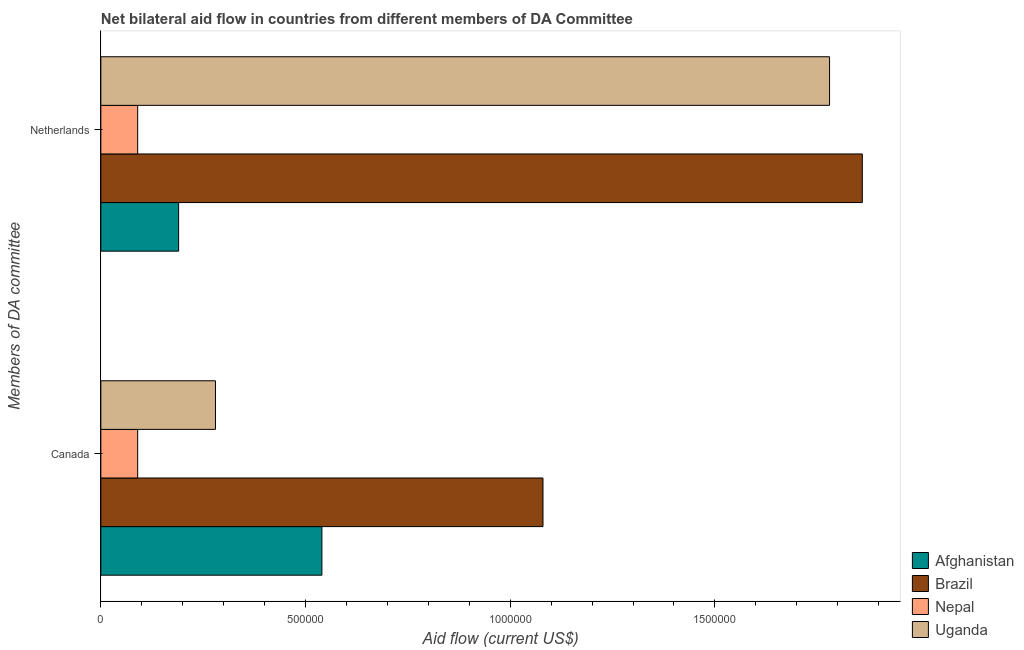How many groups of bars are there?
Offer a terse response. 2. Are the number of bars on each tick of the Y-axis equal?
Provide a succinct answer. Yes. How many bars are there on the 2nd tick from the top?
Offer a very short reply. 4. How many bars are there on the 1st tick from the bottom?
Provide a succinct answer. 4. What is the label of the 1st group of bars from the top?
Your response must be concise. Netherlands. What is the amount of aid given by canada in Uganda?
Offer a very short reply. 2.80e+05. Across all countries, what is the maximum amount of aid given by netherlands?
Provide a short and direct response. 1.86e+06. Across all countries, what is the minimum amount of aid given by netherlands?
Provide a short and direct response. 9.00e+04. In which country was the amount of aid given by netherlands maximum?
Offer a very short reply. Brazil. In which country was the amount of aid given by netherlands minimum?
Your answer should be very brief. Nepal. What is the total amount of aid given by canada in the graph?
Give a very brief answer. 1.99e+06. What is the difference between the amount of aid given by canada in Nepal and that in Brazil?
Ensure brevity in your answer.  -9.90e+05. What is the difference between the amount of aid given by canada in Afghanistan and the amount of aid given by netherlands in Uganda?
Your response must be concise. -1.24e+06. What is the average amount of aid given by canada per country?
Keep it short and to the point. 4.98e+05. What is the difference between the amount of aid given by netherlands and amount of aid given by canada in Brazil?
Keep it short and to the point. 7.80e+05. In how many countries, is the amount of aid given by netherlands greater than 1400000 US$?
Make the answer very short. 2. What is the ratio of the amount of aid given by canada in Brazil to that in Afghanistan?
Provide a short and direct response. 2. What does the 2nd bar from the top in Netherlands represents?
Provide a short and direct response. Nepal. What does the 1st bar from the bottom in Netherlands represents?
Provide a short and direct response. Afghanistan. How many bars are there?
Your answer should be compact. 8. Are all the bars in the graph horizontal?
Your response must be concise. Yes. What is the difference between two consecutive major ticks on the X-axis?
Provide a short and direct response. 5.00e+05. Are the values on the major ticks of X-axis written in scientific E-notation?
Keep it short and to the point. No. Does the graph contain grids?
Keep it short and to the point. No. How many legend labels are there?
Make the answer very short. 4. What is the title of the graph?
Give a very brief answer. Net bilateral aid flow in countries from different members of DA Committee. What is the label or title of the X-axis?
Your answer should be very brief. Aid flow (current US$). What is the label or title of the Y-axis?
Ensure brevity in your answer.  Members of DA committee. What is the Aid flow (current US$) of Afghanistan in Canada?
Provide a succinct answer. 5.40e+05. What is the Aid flow (current US$) of Brazil in Canada?
Your answer should be compact. 1.08e+06. What is the Aid flow (current US$) in Uganda in Canada?
Offer a very short reply. 2.80e+05. What is the Aid flow (current US$) of Brazil in Netherlands?
Keep it short and to the point. 1.86e+06. What is the Aid flow (current US$) of Uganda in Netherlands?
Offer a very short reply. 1.78e+06. Across all Members of DA committee, what is the maximum Aid flow (current US$) in Afghanistan?
Your answer should be compact. 5.40e+05. Across all Members of DA committee, what is the maximum Aid flow (current US$) of Brazil?
Your response must be concise. 1.86e+06. Across all Members of DA committee, what is the maximum Aid flow (current US$) in Nepal?
Offer a terse response. 9.00e+04. Across all Members of DA committee, what is the maximum Aid flow (current US$) in Uganda?
Your answer should be compact. 1.78e+06. Across all Members of DA committee, what is the minimum Aid flow (current US$) of Afghanistan?
Provide a short and direct response. 1.90e+05. Across all Members of DA committee, what is the minimum Aid flow (current US$) of Brazil?
Your answer should be compact. 1.08e+06. Across all Members of DA committee, what is the minimum Aid flow (current US$) in Nepal?
Ensure brevity in your answer.  9.00e+04. What is the total Aid flow (current US$) in Afghanistan in the graph?
Ensure brevity in your answer.  7.30e+05. What is the total Aid flow (current US$) of Brazil in the graph?
Provide a succinct answer. 2.94e+06. What is the total Aid flow (current US$) in Nepal in the graph?
Offer a terse response. 1.80e+05. What is the total Aid flow (current US$) of Uganda in the graph?
Your response must be concise. 2.06e+06. What is the difference between the Aid flow (current US$) of Brazil in Canada and that in Netherlands?
Provide a short and direct response. -7.80e+05. What is the difference between the Aid flow (current US$) of Uganda in Canada and that in Netherlands?
Provide a succinct answer. -1.50e+06. What is the difference between the Aid flow (current US$) of Afghanistan in Canada and the Aid flow (current US$) of Brazil in Netherlands?
Your answer should be compact. -1.32e+06. What is the difference between the Aid flow (current US$) of Afghanistan in Canada and the Aid flow (current US$) of Uganda in Netherlands?
Offer a very short reply. -1.24e+06. What is the difference between the Aid flow (current US$) of Brazil in Canada and the Aid flow (current US$) of Nepal in Netherlands?
Your response must be concise. 9.90e+05. What is the difference between the Aid flow (current US$) of Brazil in Canada and the Aid flow (current US$) of Uganda in Netherlands?
Your answer should be compact. -7.00e+05. What is the difference between the Aid flow (current US$) in Nepal in Canada and the Aid flow (current US$) in Uganda in Netherlands?
Keep it short and to the point. -1.69e+06. What is the average Aid flow (current US$) of Afghanistan per Members of DA committee?
Keep it short and to the point. 3.65e+05. What is the average Aid flow (current US$) of Brazil per Members of DA committee?
Your response must be concise. 1.47e+06. What is the average Aid flow (current US$) in Nepal per Members of DA committee?
Ensure brevity in your answer.  9.00e+04. What is the average Aid flow (current US$) in Uganda per Members of DA committee?
Your answer should be very brief. 1.03e+06. What is the difference between the Aid flow (current US$) in Afghanistan and Aid flow (current US$) in Brazil in Canada?
Provide a succinct answer. -5.40e+05. What is the difference between the Aid flow (current US$) in Afghanistan and Aid flow (current US$) in Nepal in Canada?
Provide a short and direct response. 4.50e+05. What is the difference between the Aid flow (current US$) of Afghanistan and Aid flow (current US$) of Uganda in Canada?
Provide a succinct answer. 2.60e+05. What is the difference between the Aid flow (current US$) in Brazil and Aid flow (current US$) in Nepal in Canada?
Provide a succinct answer. 9.90e+05. What is the difference between the Aid flow (current US$) in Brazil and Aid flow (current US$) in Uganda in Canada?
Ensure brevity in your answer.  8.00e+05. What is the difference between the Aid flow (current US$) in Afghanistan and Aid flow (current US$) in Brazil in Netherlands?
Keep it short and to the point. -1.67e+06. What is the difference between the Aid flow (current US$) in Afghanistan and Aid flow (current US$) in Uganda in Netherlands?
Keep it short and to the point. -1.59e+06. What is the difference between the Aid flow (current US$) in Brazil and Aid flow (current US$) in Nepal in Netherlands?
Give a very brief answer. 1.77e+06. What is the difference between the Aid flow (current US$) of Brazil and Aid flow (current US$) of Uganda in Netherlands?
Provide a succinct answer. 8.00e+04. What is the difference between the Aid flow (current US$) of Nepal and Aid flow (current US$) of Uganda in Netherlands?
Make the answer very short. -1.69e+06. What is the ratio of the Aid flow (current US$) of Afghanistan in Canada to that in Netherlands?
Your answer should be very brief. 2.84. What is the ratio of the Aid flow (current US$) of Brazil in Canada to that in Netherlands?
Your answer should be compact. 0.58. What is the ratio of the Aid flow (current US$) of Nepal in Canada to that in Netherlands?
Keep it short and to the point. 1. What is the ratio of the Aid flow (current US$) of Uganda in Canada to that in Netherlands?
Ensure brevity in your answer.  0.16. What is the difference between the highest and the second highest Aid flow (current US$) in Brazil?
Provide a short and direct response. 7.80e+05. What is the difference between the highest and the second highest Aid flow (current US$) in Nepal?
Give a very brief answer. 0. What is the difference between the highest and the second highest Aid flow (current US$) in Uganda?
Offer a very short reply. 1.50e+06. What is the difference between the highest and the lowest Aid flow (current US$) of Brazil?
Make the answer very short. 7.80e+05. What is the difference between the highest and the lowest Aid flow (current US$) in Uganda?
Keep it short and to the point. 1.50e+06. 